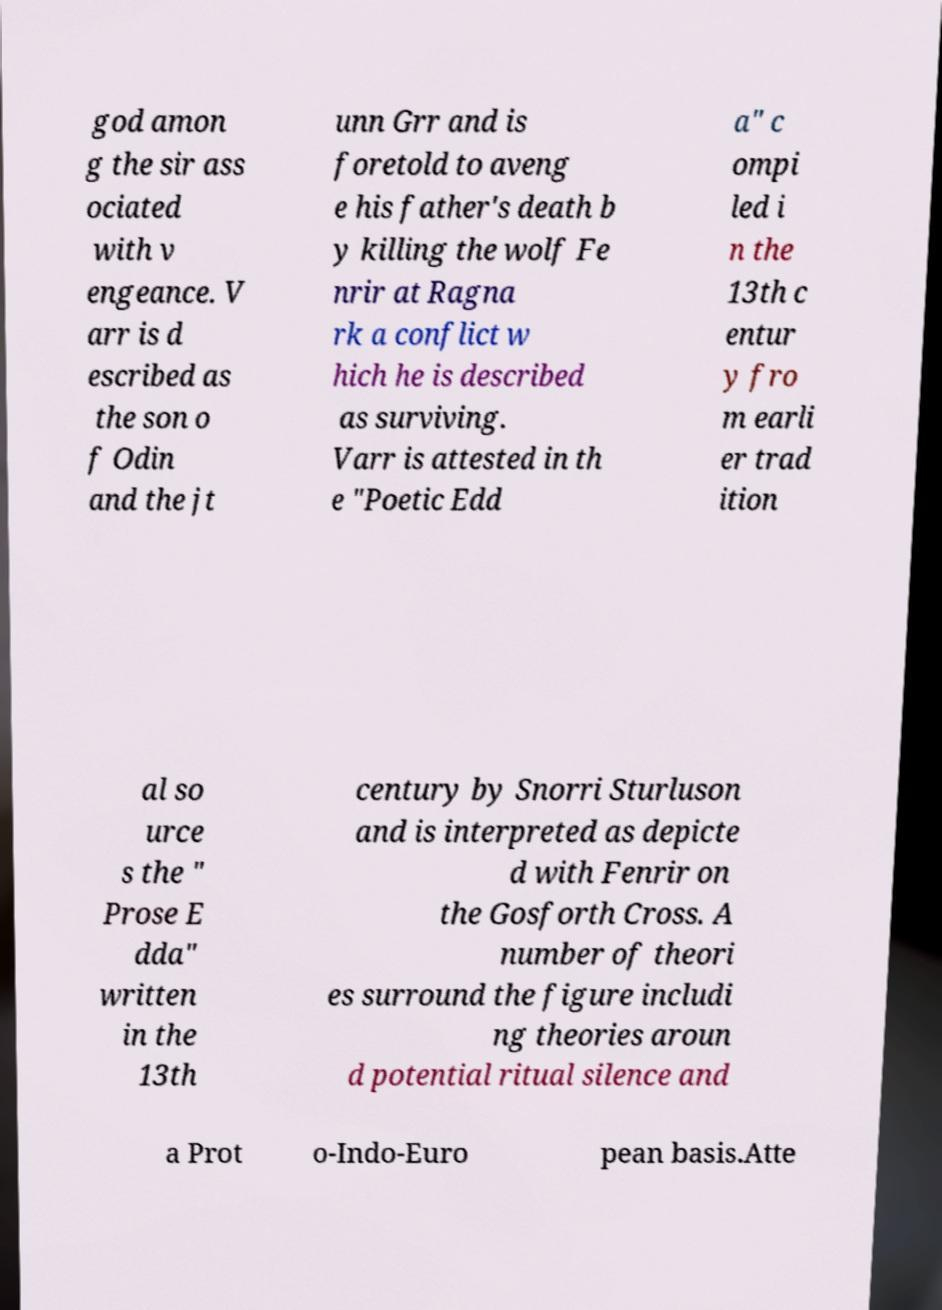Can you accurately transcribe the text from the provided image for me? god amon g the sir ass ociated with v engeance. V arr is d escribed as the son o f Odin and the jt unn Grr and is foretold to aveng e his father's death b y killing the wolf Fe nrir at Ragna rk a conflict w hich he is described as surviving. Varr is attested in th e "Poetic Edd a" c ompi led i n the 13th c entur y fro m earli er trad ition al so urce s the " Prose E dda" written in the 13th century by Snorri Sturluson and is interpreted as depicte d with Fenrir on the Gosforth Cross. A number of theori es surround the figure includi ng theories aroun d potential ritual silence and a Prot o-Indo-Euro pean basis.Atte 